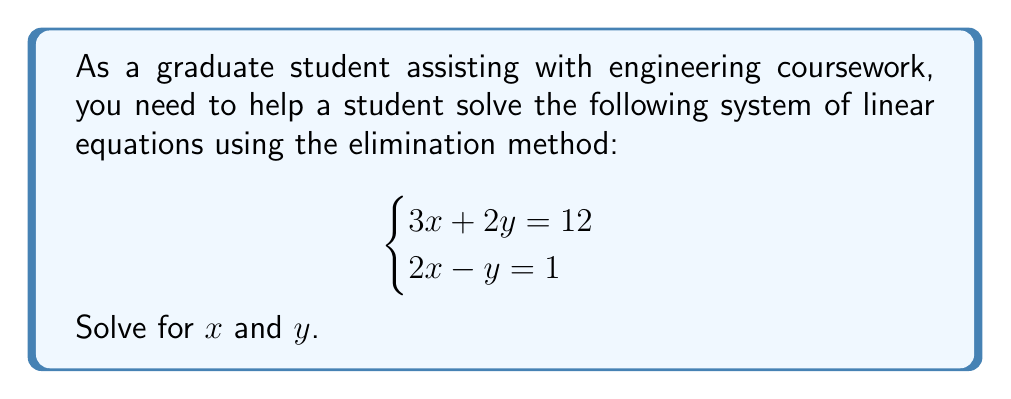Give your solution to this math problem. To solve this system using the elimination method, we'll follow these steps:

1) First, we need to eliminate one of the variables. Let's choose to eliminate $y$. To do this, we'll multiply the second equation by 2 to make the $y$ terms have the same magnitude:

   Equation 1: $3x + 2y = 12$
   Equation 2: $2x - y = 1$ (multiply by 2)
   Equation 2': $4x - 2y = 2$

2) Now, add the two equations:

   $(3x + 2y) + (4x - 2y) = 12 + 2$
   $7x = 14$

3) Solve for $x$:

   $x = 14 \div 7 = 2$

4) Now that we know $x = 2$, substitute this value into one of the original equations to solve for $y$. Let's use the first equation:

   $3x + 2y = 12$
   $3(2) + 2y = 12$
   $6 + 2y = 12$
   $2y = 12 - 6 = 6$
   $y = 6 \div 2 = 3$

5) Check the solution by substituting the values back into both original equations:

   Equation 1: $3(2) + 2(3) = 6 + 6 = 12$ (True)
   Equation 2: $2(2) - 3 = 4 - 3 = 1$ (True)

Therefore, the solution satisfies both equations.
Answer: $x = 2$, $y = 3$ 